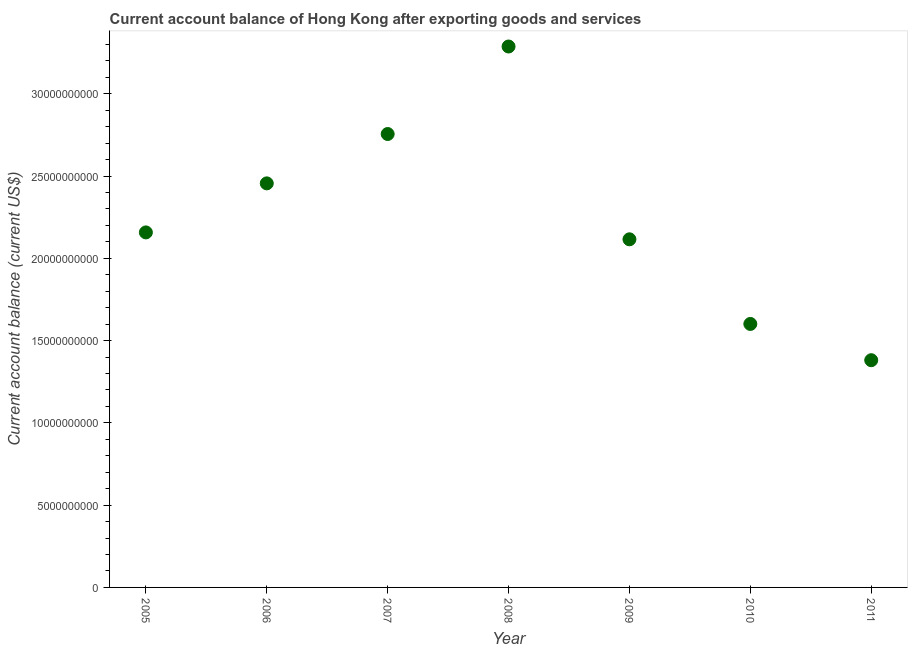What is the current account balance in 2006?
Your answer should be compact. 2.46e+1. Across all years, what is the maximum current account balance?
Provide a short and direct response. 3.29e+1. Across all years, what is the minimum current account balance?
Provide a short and direct response. 1.38e+1. In which year was the current account balance maximum?
Your answer should be very brief. 2008. In which year was the current account balance minimum?
Your answer should be compact. 2011. What is the sum of the current account balance?
Your answer should be very brief. 1.58e+11. What is the difference between the current account balance in 2008 and 2009?
Make the answer very short. 1.17e+1. What is the average current account balance per year?
Keep it short and to the point. 2.25e+1. What is the median current account balance?
Offer a very short reply. 2.16e+1. What is the ratio of the current account balance in 2008 to that in 2010?
Your answer should be very brief. 2.05. Is the current account balance in 2008 less than that in 2009?
Make the answer very short. No. What is the difference between the highest and the second highest current account balance?
Offer a terse response. 5.32e+09. What is the difference between the highest and the lowest current account balance?
Keep it short and to the point. 1.91e+1. In how many years, is the current account balance greater than the average current account balance taken over all years?
Your response must be concise. 3. Does the current account balance monotonically increase over the years?
Provide a succinct answer. No. How many dotlines are there?
Provide a short and direct response. 1. What is the difference between two consecutive major ticks on the Y-axis?
Give a very brief answer. 5.00e+09. Does the graph contain any zero values?
Provide a succinct answer. No. Does the graph contain grids?
Provide a short and direct response. No. What is the title of the graph?
Provide a short and direct response. Current account balance of Hong Kong after exporting goods and services. What is the label or title of the X-axis?
Offer a very short reply. Year. What is the label or title of the Y-axis?
Offer a very short reply. Current account balance (current US$). What is the Current account balance (current US$) in 2005?
Your answer should be compact. 2.16e+1. What is the Current account balance (current US$) in 2006?
Ensure brevity in your answer.  2.46e+1. What is the Current account balance (current US$) in 2007?
Provide a succinct answer. 2.76e+1. What is the Current account balance (current US$) in 2008?
Make the answer very short. 3.29e+1. What is the Current account balance (current US$) in 2009?
Offer a terse response. 2.12e+1. What is the Current account balance (current US$) in 2010?
Your answer should be compact. 1.60e+1. What is the Current account balance (current US$) in 2011?
Provide a succinct answer. 1.38e+1. What is the difference between the Current account balance (current US$) in 2005 and 2006?
Your answer should be compact. -2.98e+09. What is the difference between the Current account balance (current US$) in 2005 and 2007?
Give a very brief answer. -5.98e+09. What is the difference between the Current account balance (current US$) in 2005 and 2008?
Keep it short and to the point. -1.13e+1. What is the difference between the Current account balance (current US$) in 2005 and 2009?
Your answer should be compact. 4.19e+08. What is the difference between the Current account balance (current US$) in 2005 and 2010?
Provide a succinct answer. 5.56e+09. What is the difference between the Current account balance (current US$) in 2005 and 2011?
Offer a very short reply. 7.77e+09. What is the difference between the Current account balance (current US$) in 2006 and 2007?
Your response must be concise. -3.00e+09. What is the difference between the Current account balance (current US$) in 2006 and 2008?
Your response must be concise. -8.32e+09. What is the difference between the Current account balance (current US$) in 2006 and 2009?
Your answer should be very brief. 3.40e+09. What is the difference between the Current account balance (current US$) in 2006 and 2010?
Give a very brief answer. 8.54e+09. What is the difference between the Current account balance (current US$) in 2006 and 2011?
Keep it short and to the point. 1.07e+1. What is the difference between the Current account balance (current US$) in 2007 and 2008?
Offer a very short reply. -5.32e+09. What is the difference between the Current account balance (current US$) in 2007 and 2009?
Your answer should be compact. 6.40e+09. What is the difference between the Current account balance (current US$) in 2007 and 2010?
Provide a succinct answer. 1.15e+1. What is the difference between the Current account balance (current US$) in 2007 and 2011?
Offer a very short reply. 1.37e+1. What is the difference between the Current account balance (current US$) in 2008 and 2009?
Ensure brevity in your answer.  1.17e+1. What is the difference between the Current account balance (current US$) in 2008 and 2010?
Provide a succinct answer. 1.69e+1. What is the difference between the Current account balance (current US$) in 2008 and 2011?
Make the answer very short. 1.91e+1. What is the difference between the Current account balance (current US$) in 2009 and 2010?
Your answer should be compact. 5.14e+09. What is the difference between the Current account balance (current US$) in 2009 and 2011?
Make the answer very short. 7.35e+09. What is the difference between the Current account balance (current US$) in 2010 and 2011?
Provide a succinct answer. 2.20e+09. What is the ratio of the Current account balance (current US$) in 2005 to that in 2006?
Provide a short and direct response. 0.88. What is the ratio of the Current account balance (current US$) in 2005 to that in 2007?
Provide a succinct answer. 0.78. What is the ratio of the Current account balance (current US$) in 2005 to that in 2008?
Provide a short and direct response. 0.66. What is the ratio of the Current account balance (current US$) in 2005 to that in 2009?
Ensure brevity in your answer.  1.02. What is the ratio of the Current account balance (current US$) in 2005 to that in 2010?
Provide a short and direct response. 1.35. What is the ratio of the Current account balance (current US$) in 2005 to that in 2011?
Ensure brevity in your answer.  1.56. What is the ratio of the Current account balance (current US$) in 2006 to that in 2007?
Ensure brevity in your answer.  0.89. What is the ratio of the Current account balance (current US$) in 2006 to that in 2008?
Offer a very short reply. 0.75. What is the ratio of the Current account balance (current US$) in 2006 to that in 2009?
Your answer should be compact. 1.16. What is the ratio of the Current account balance (current US$) in 2006 to that in 2010?
Provide a short and direct response. 1.53. What is the ratio of the Current account balance (current US$) in 2006 to that in 2011?
Your answer should be compact. 1.78. What is the ratio of the Current account balance (current US$) in 2007 to that in 2008?
Your response must be concise. 0.84. What is the ratio of the Current account balance (current US$) in 2007 to that in 2009?
Provide a succinct answer. 1.3. What is the ratio of the Current account balance (current US$) in 2007 to that in 2010?
Offer a very short reply. 1.72. What is the ratio of the Current account balance (current US$) in 2007 to that in 2011?
Make the answer very short. 2. What is the ratio of the Current account balance (current US$) in 2008 to that in 2009?
Your answer should be compact. 1.55. What is the ratio of the Current account balance (current US$) in 2008 to that in 2010?
Offer a terse response. 2.05. What is the ratio of the Current account balance (current US$) in 2008 to that in 2011?
Your response must be concise. 2.38. What is the ratio of the Current account balance (current US$) in 2009 to that in 2010?
Ensure brevity in your answer.  1.32. What is the ratio of the Current account balance (current US$) in 2009 to that in 2011?
Your response must be concise. 1.53. What is the ratio of the Current account balance (current US$) in 2010 to that in 2011?
Offer a very short reply. 1.16. 